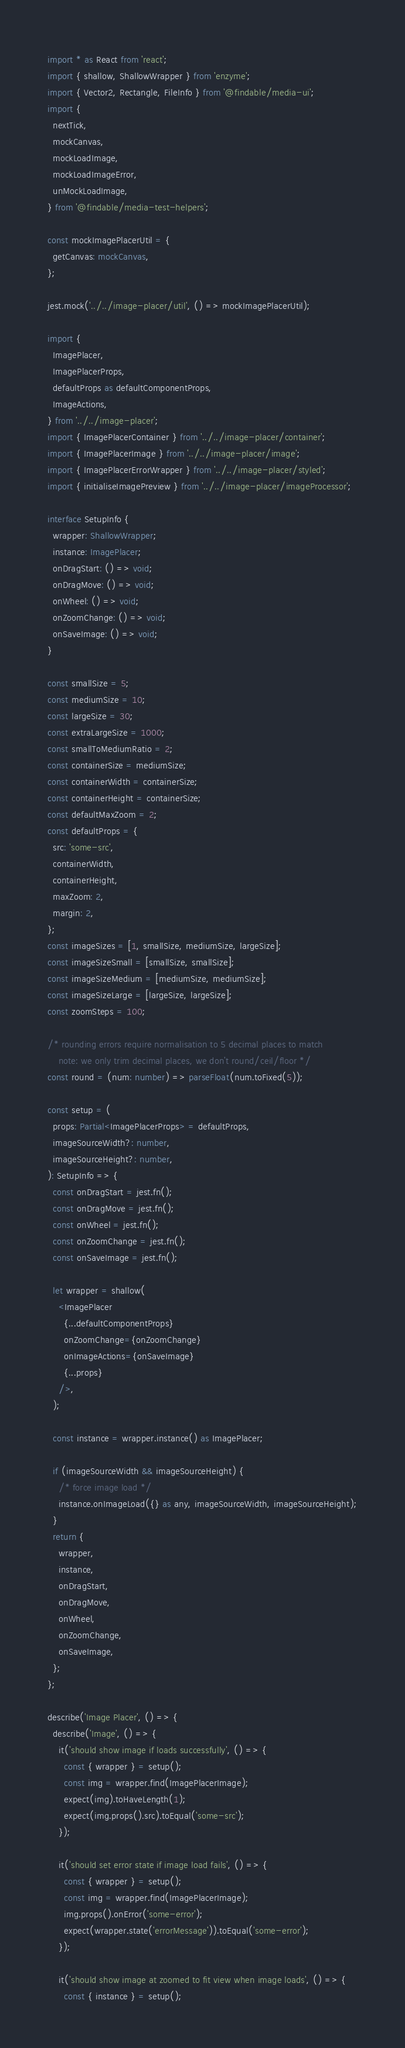Convert code to text. <code><loc_0><loc_0><loc_500><loc_500><_TypeScript_>import * as React from 'react';
import { shallow, ShallowWrapper } from 'enzyme';
import { Vector2, Rectangle, FileInfo } from '@findable/media-ui';
import {
  nextTick,
  mockCanvas,
  mockLoadImage,
  mockLoadImageError,
  unMockLoadImage,
} from '@findable/media-test-helpers';

const mockImagePlacerUtil = {
  getCanvas: mockCanvas,
};

jest.mock('../../image-placer/util', () => mockImagePlacerUtil);

import {
  ImagePlacer,
  ImagePlacerProps,
  defaultProps as defaultComponentProps,
  ImageActions,
} from '../../image-placer';
import { ImagePlacerContainer } from '../../image-placer/container';
import { ImagePlacerImage } from '../../image-placer/image';
import { ImagePlacerErrorWrapper } from '../../image-placer/styled';
import { initialiseImagePreview } from '../../image-placer/imageProcessor';

interface SetupInfo {
  wrapper: ShallowWrapper;
  instance: ImagePlacer;
  onDragStart: () => void;
  onDragMove: () => void;
  onWheel: () => void;
  onZoomChange: () => void;
  onSaveImage: () => void;
}

const smallSize = 5;
const mediumSize = 10;
const largeSize = 30;
const extraLargeSize = 1000;
const smallToMediumRatio = 2;
const containerSize = mediumSize;
const containerWidth = containerSize;
const containerHeight = containerSize;
const defaultMaxZoom = 2;
const defaultProps = {
  src: 'some-src',
  containerWidth,
  containerHeight,
  maxZoom: 2,
  margin: 2,
};
const imageSizes = [1, smallSize, mediumSize, largeSize];
const imageSizeSmall = [smallSize, smallSize];
const imageSizeMedium = [mediumSize, mediumSize];
const imageSizeLarge = [largeSize, largeSize];
const zoomSteps = 100;

/* rounding errors require normalisation to 5 decimal places to match
    note: we only trim decimal places, we don't round/ceil/floor */
const round = (num: number) => parseFloat(num.toFixed(5));

const setup = (
  props: Partial<ImagePlacerProps> = defaultProps,
  imageSourceWidth?: number,
  imageSourceHeight?: number,
): SetupInfo => {
  const onDragStart = jest.fn();
  const onDragMove = jest.fn();
  const onWheel = jest.fn();
  const onZoomChange = jest.fn();
  const onSaveImage = jest.fn();

  let wrapper = shallow(
    <ImagePlacer
      {...defaultComponentProps}
      onZoomChange={onZoomChange}
      onImageActions={onSaveImage}
      {...props}
    />,
  );

  const instance = wrapper.instance() as ImagePlacer;

  if (imageSourceWidth && imageSourceHeight) {
    /* force image load */
    instance.onImageLoad({} as any, imageSourceWidth, imageSourceHeight);
  }
  return {
    wrapper,
    instance,
    onDragStart,
    onDragMove,
    onWheel,
    onZoomChange,
    onSaveImage,
  };
};

describe('Image Placer', () => {
  describe('Image', () => {
    it('should show image if loads successfully', () => {
      const { wrapper } = setup();
      const img = wrapper.find(ImagePlacerImage);
      expect(img).toHaveLength(1);
      expect(img.props().src).toEqual('some-src');
    });

    it('should set error state if image load fails', () => {
      const { wrapper } = setup();
      const img = wrapper.find(ImagePlacerImage);
      img.props().onError('some-error');
      expect(wrapper.state('errorMessage')).toEqual('some-error');
    });

    it('should show image at zoomed to fit view when image loads', () => {
      const { instance } = setup();</code> 